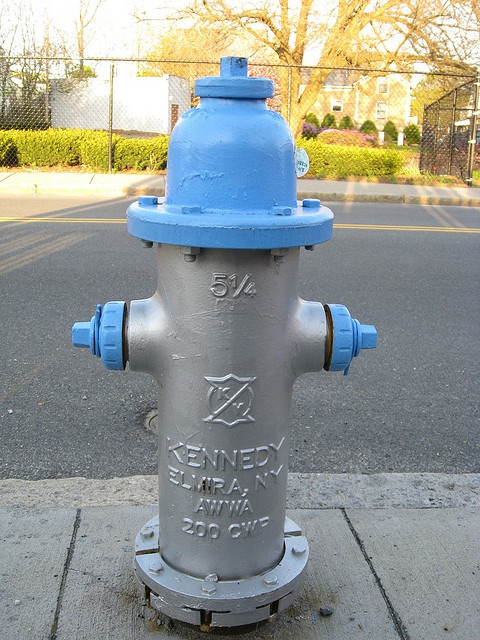Describe the objects in this image and their specific colors. I can see a fire hydrant in white, gray, lightblue, and darkgray tones in this image. 